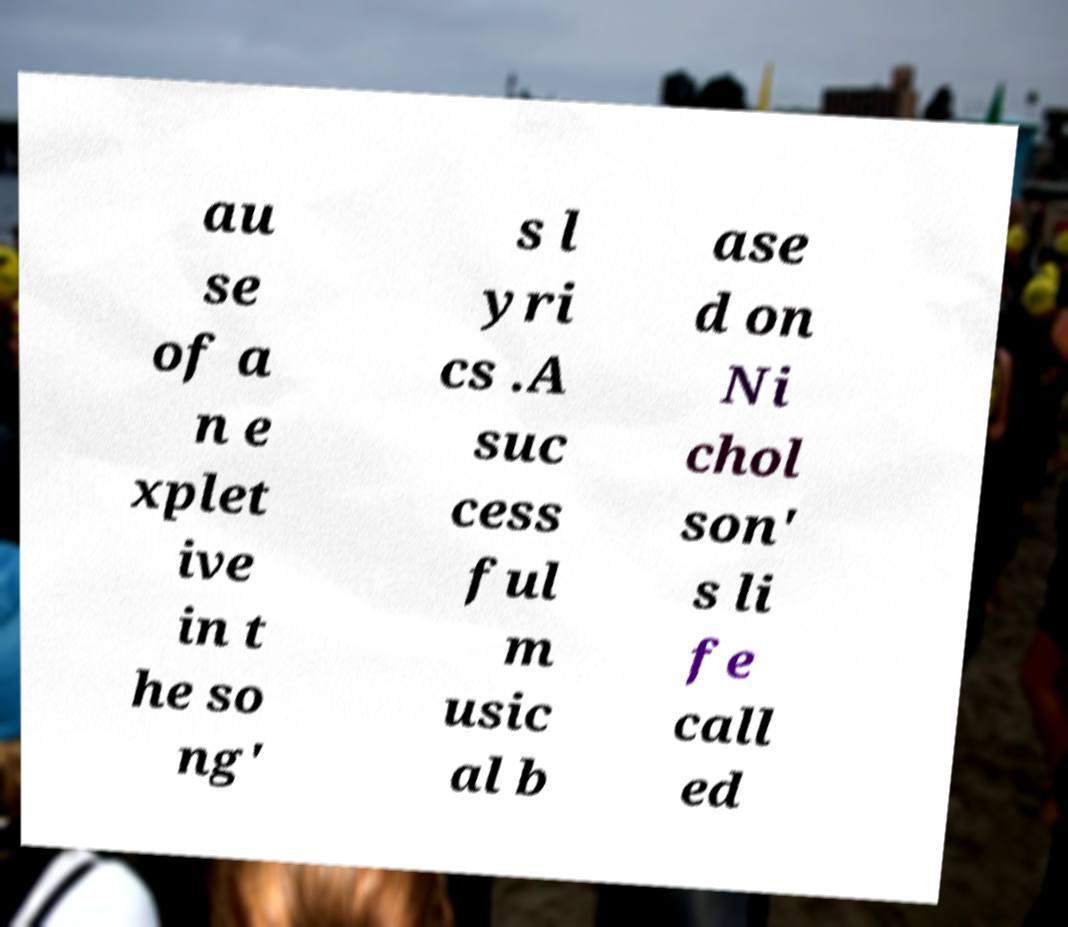Please read and relay the text visible in this image. What does it say? au se of a n e xplet ive in t he so ng' s l yri cs .A suc cess ful m usic al b ase d on Ni chol son' s li fe call ed 